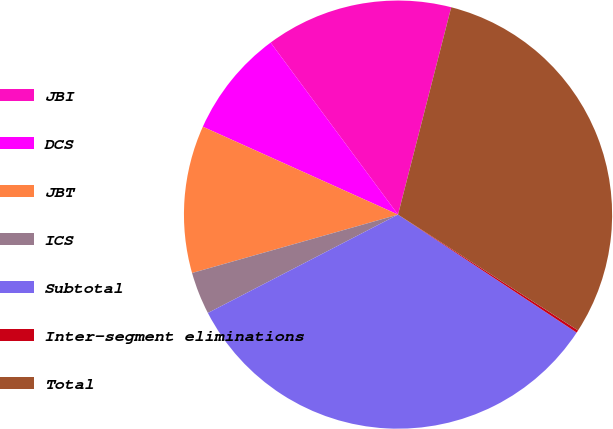<chart> <loc_0><loc_0><loc_500><loc_500><pie_chart><fcel>JBI<fcel>DCS<fcel>JBT<fcel>ICS<fcel>Subtotal<fcel>Inter-segment eliminations<fcel>Total<nl><fcel>14.14%<fcel>8.12%<fcel>11.13%<fcel>3.2%<fcel>33.11%<fcel>0.19%<fcel>30.1%<nl></chart> 